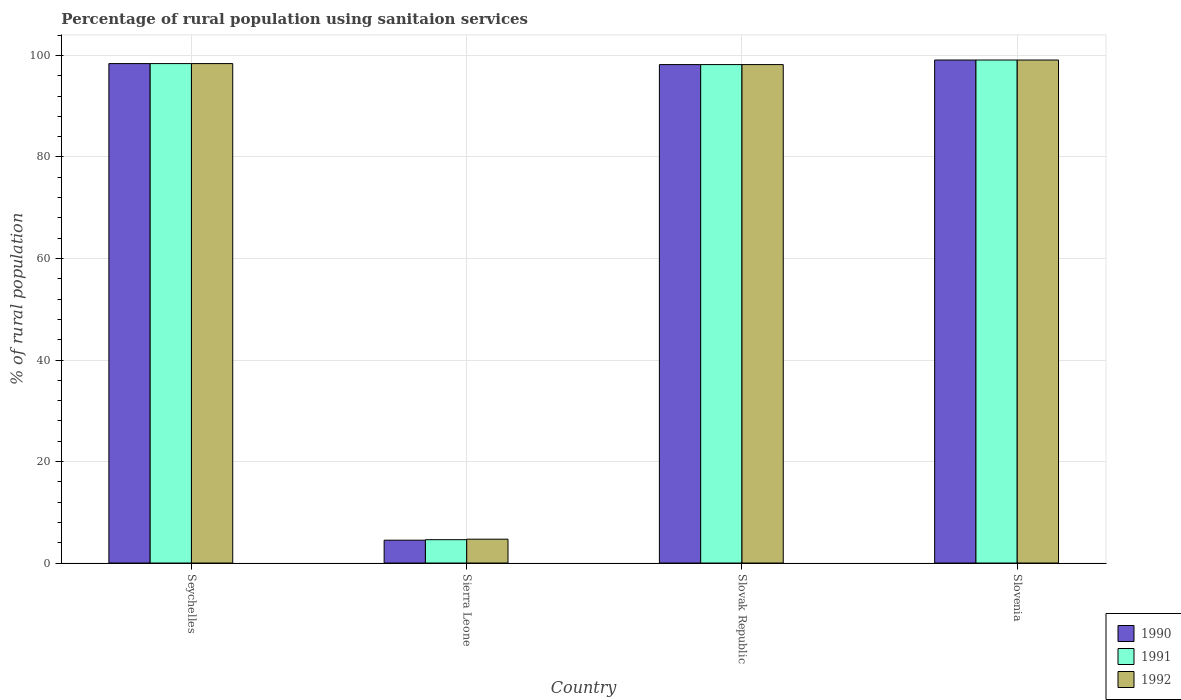How many groups of bars are there?
Provide a short and direct response. 4. Are the number of bars per tick equal to the number of legend labels?
Your response must be concise. Yes. How many bars are there on the 1st tick from the left?
Provide a succinct answer. 3. How many bars are there on the 2nd tick from the right?
Offer a terse response. 3. What is the label of the 4th group of bars from the left?
Offer a terse response. Slovenia. In how many cases, is the number of bars for a given country not equal to the number of legend labels?
Your answer should be very brief. 0. What is the percentage of rural population using sanitaion services in 1990 in Seychelles?
Provide a succinct answer. 98.4. Across all countries, what is the maximum percentage of rural population using sanitaion services in 1992?
Your answer should be very brief. 99.1. Across all countries, what is the minimum percentage of rural population using sanitaion services in 1992?
Keep it short and to the point. 4.7. In which country was the percentage of rural population using sanitaion services in 1992 maximum?
Ensure brevity in your answer.  Slovenia. In which country was the percentage of rural population using sanitaion services in 1991 minimum?
Make the answer very short. Sierra Leone. What is the total percentage of rural population using sanitaion services in 1990 in the graph?
Make the answer very short. 300.2. What is the difference between the percentage of rural population using sanitaion services in 1992 in Seychelles and that in Sierra Leone?
Make the answer very short. 93.7. What is the difference between the percentage of rural population using sanitaion services in 1992 in Seychelles and the percentage of rural population using sanitaion services in 1990 in Slovenia?
Your answer should be compact. -0.7. What is the average percentage of rural population using sanitaion services in 1990 per country?
Provide a succinct answer. 75.05. What is the ratio of the percentage of rural population using sanitaion services in 1992 in Seychelles to that in Slovenia?
Provide a succinct answer. 0.99. Is the percentage of rural population using sanitaion services in 1992 in Sierra Leone less than that in Slovak Republic?
Provide a succinct answer. Yes. What is the difference between the highest and the second highest percentage of rural population using sanitaion services in 1992?
Provide a short and direct response. -0.7. What is the difference between the highest and the lowest percentage of rural population using sanitaion services in 1991?
Your answer should be very brief. 94.5. Is the sum of the percentage of rural population using sanitaion services in 1990 in Slovak Republic and Slovenia greater than the maximum percentage of rural population using sanitaion services in 1991 across all countries?
Make the answer very short. Yes. What does the 1st bar from the right in Slovenia represents?
Your response must be concise. 1992. How many bars are there?
Offer a terse response. 12. Are the values on the major ticks of Y-axis written in scientific E-notation?
Provide a succinct answer. No. Does the graph contain any zero values?
Your answer should be very brief. No. Does the graph contain grids?
Provide a succinct answer. Yes. Where does the legend appear in the graph?
Give a very brief answer. Bottom right. How many legend labels are there?
Provide a succinct answer. 3. What is the title of the graph?
Give a very brief answer. Percentage of rural population using sanitaion services. What is the label or title of the Y-axis?
Provide a short and direct response. % of rural population. What is the % of rural population of 1990 in Seychelles?
Give a very brief answer. 98.4. What is the % of rural population of 1991 in Seychelles?
Provide a short and direct response. 98.4. What is the % of rural population of 1992 in Seychelles?
Make the answer very short. 98.4. What is the % of rural population in 1992 in Sierra Leone?
Provide a succinct answer. 4.7. What is the % of rural population of 1990 in Slovak Republic?
Your answer should be compact. 98.2. What is the % of rural population of 1991 in Slovak Republic?
Provide a succinct answer. 98.2. What is the % of rural population of 1992 in Slovak Republic?
Give a very brief answer. 98.2. What is the % of rural population in 1990 in Slovenia?
Your answer should be very brief. 99.1. What is the % of rural population in 1991 in Slovenia?
Give a very brief answer. 99.1. What is the % of rural population in 1992 in Slovenia?
Your response must be concise. 99.1. Across all countries, what is the maximum % of rural population of 1990?
Your answer should be very brief. 99.1. Across all countries, what is the maximum % of rural population of 1991?
Provide a short and direct response. 99.1. Across all countries, what is the maximum % of rural population in 1992?
Keep it short and to the point. 99.1. Across all countries, what is the minimum % of rural population in 1992?
Your answer should be compact. 4.7. What is the total % of rural population of 1990 in the graph?
Provide a short and direct response. 300.2. What is the total % of rural population of 1991 in the graph?
Provide a succinct answer. 300.3. What is the total % of rural population in 1992 in the graph?
Provide a succinct answer. 300.4. What is the difference between the % of rural population in 1990 in Seychelles and that in Sierra Leone?
Offer a very short reply. 93.9. What is the difference between the % of rural population in 1991 in Seychelles and that in Sierra Leone?
Your answer should be very brief. 93.8. What is the difference between the % of rural population in 1992 in Seychelles and that in Sierra Leone?
Your response must be concise. 93.7. What is the difference between the % of rural population of 1991 in Seychelles and that in Slovak Republic?
Make the answer very short. 0.2. What is the difference between the % of rural population in 1992 in Seychelles and that in Slovak Republic?
Ensure brevity in your answer.  0.2. What is the difference between the % of rural population of 1990 in Seychelles and that in Slovenia?
Keep it short and to the point. -0.7. What is the difference between the % of rural population in 1991 in Seychelles and that in Slovenia?
Give a very brief answer. -0.7. What is the difference between the % of rural population of 1992 in Seychelles and that in Slovenia?
Offer a very short reply. -0.7. What is the difference between the % of rural population of 1990 in Sierra Leone and that in Slovak Republic?
Keep it short and to the point. -93.7. What is the difference between the % of rural population of 1991 in Sierra Leone and that in Slovak Republic?
Make the answer very short. -93.6. What is the difference between the % of rural population of 1992 in Sierra Leone and that in Slovak Republic?
Make the answer very short. -93.5. What is the difference between the % of rural population of 1990 in Sierra Leone and that in Slovenia?
Your answer should be very brief. -94.6. What is the difference between the % of rural population in 1991 in Sierra Leone and that in Slovenia?
Your answer should be compact. -94.5. What is the difference between the % of rural population of 1992 in Sierra Leone and that in Slovenia?
Your answer should be very brief. -94.4. What is the difference between the % of rural population in 1990 in Seychelles and the % of rural population in 1991 in Sierra Leone?
Offer a very short reply. 93.8. What is the difference between the % of rural population in 1990 in Seychelles and the % of rural population in 1992 in Sierra Leone?
Make the answer very short. 93.7. What is the difference between the % of rural population in 1991 in Seychelles and the % of rural population in 1992 in Sierra Leone?
Offer a terse response. 93.7. What is the difference between the % of rural population in 1990 in Seychelles and the % of rural population in 1992 in Slovak Republic?
Keep it short and to the point. 0.2. What is the difference between the % of rural population of 1991 in Seychelles and the % of rural population of 1992 in Slovak Republic?
Provide a succinct answer. 0.2. What is the difference between the % of rural population of 1990 in Seychelles and the % of rural population of 1991 in Slovenia?
Ensure brevity in your answer.  -0.7. What is the difference between the % of rural population of 1991 in Seychelles and the % of rural population of 1992 in Slovenia?
Offer a very short reply. -0.7. What is the difference between the % of rural population in 1990 in Sierra Leone and the % of rural population in 1991 in Slovak Republic?
Your response must be concise. -93.7. What is the difference between the % of rural population in 1990 in Sierra Leone and the % of rural population in 1992 in Slovak Republic?
Provide a succinct answer. -93.7. What is the difference between the % of rural population in 1991 in Sierra Leone and the % of rural population in 1992 in Slovak Republic?
Provide a succinct answer. -93.6. What is the difference between the % of rural population in 1990 in Sierra Leone and the % of rural population in 1991 in Slovenia?
Make the answer very short. -94.6. What is the difference between the % of rural population of 1990 in Sierra Leone and the % of rural population of 1992 in Slovenia?
Make the answer very short. -94.6. What is the difference between the % of rural population in 1991 in Sierra Leone and the % of rural population in 1992 in Slovenia?
Ensure brevity in your answer.  -94.5. What is the average % of rural population in 1990 per country?
Your answer should be compact. 75.05. What is the average % of rural population in 1991 per country?
Provide a short and direct response. 75.08. What is the average % of rural population of 1992 per country?
Make the answer very short. 75.1. What is the difference between the % of rural population in 1990 and % of rural population in 1991 in Seychelles?
Make the answer very short. 0. What is the difference between the % of rural population in 1990 and % of rural population in 1991 in Sierra Leone?
Your answer should be compact. -0.1. What is the difference between the % of rural population of 1990 and % of rural population of 1992 in Slovak Republic?
Make the answer very short. 0. What is the difference between the % of rural population in 1991 and % of rural population in 1992 in Slovak Republic?
Give a very brief answer. 0. What is the ratio of the % of rural population in 1990 in Seychelles to that in Sierra Leone?
Keep it short and to the point. 21.87. What is the ratio of the % of rural population of 1991 in Seychelles to that in Sierra Leone?
Provide a short and direct response. 21.39. What is the ratio of the % of rural population of 1992 in Seychelles to that in Sierra Leone?
Give a very brief answer. 20.94. What is the ratio of the % of rural population in 1990 in Seychelles to that in Slovak Republic?
Give a very brief answer. 1. What is the ratio of the % of rural population in 1991 in Seychelles to that in Slovak Republic?
Your answer should be compact. 1. What is the ratio of the % of rural population of 1992 in Seychelles to that in Slovak Republic?
Your answer should be very brief. 1. What is the ratio of the % of rural population in 1991 in Seychelles to that in Slovenia?
Offer a very short reply. 0.99. What is the ratio of the % of rural population in 1990 in Sierra Leone to that in Slovak Republic?
Make the answer very short. 0.05. What is the ratio of the % of rural population in 1991 in Sierra Leone to that in Slovak Republic?
Make the answer very short. 0.05. What is the ratio of the % of rural population of 1992 in Sierra Leone to that in Slovak Republic?
Your response must be concise. 0.05. What is the ratio of the % of rural population of 1990 in Sierra Leone to that in Slovenia?
Ensure brevity in your answer.  0.05. What is the ratio of the % of rural population in 1991 in Sierra Leone to that in Slovenia?
Provide a short and direct response. 0.05. What is the ratio of the % of rural population in 1992 in Sierra Leone to that in Slovenia?
Your answer should be compact. 0.05. What is the ratio of the % of rural population of 1990 in Slovak Republic to that in Slovenia?
Your answer should be very brief. 0.99. What is the ratio of the % of rural population of 1991 in Slovak Republic to that in Slovenia?
Give a very brief answer. 0.99. What is the ratio of the % of rural population in 1992 in Slovak Republic to that in Slovenia?
Offer a terse response. 0.99. What is the difference between the highest and the second highest % of rural population of 1990?
Make the answer very short. 0.7. What is the difference between the highest and the second highest % of rural population of 1992?
Make the answer very short. 0.7. What is the difference between the highest and the lowest % of rural population in 1990?
Offer a terse response. 94.6. What is the difference between the highest and the lowest % of rural population of 1991?
Your answer should be compact. 94.5. What is the difference between the highest and the lowest % of rural population of 1992?
Offer a very short reply. 94.4. 